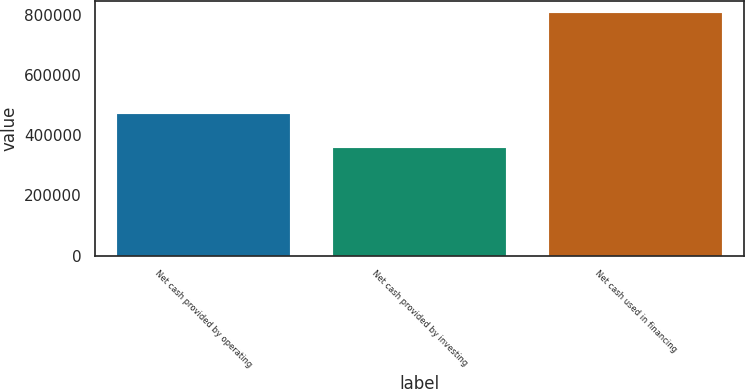<chart> <loc_0><loc_0><loc_500><loc_500><bar_chart><fcel>Net cash provided by operating<fcel>Net cash provided by investing<fcel>Net cash used in financing<nl><fcel>472249<fcel>356605<fcel>806702<nl></chart> 